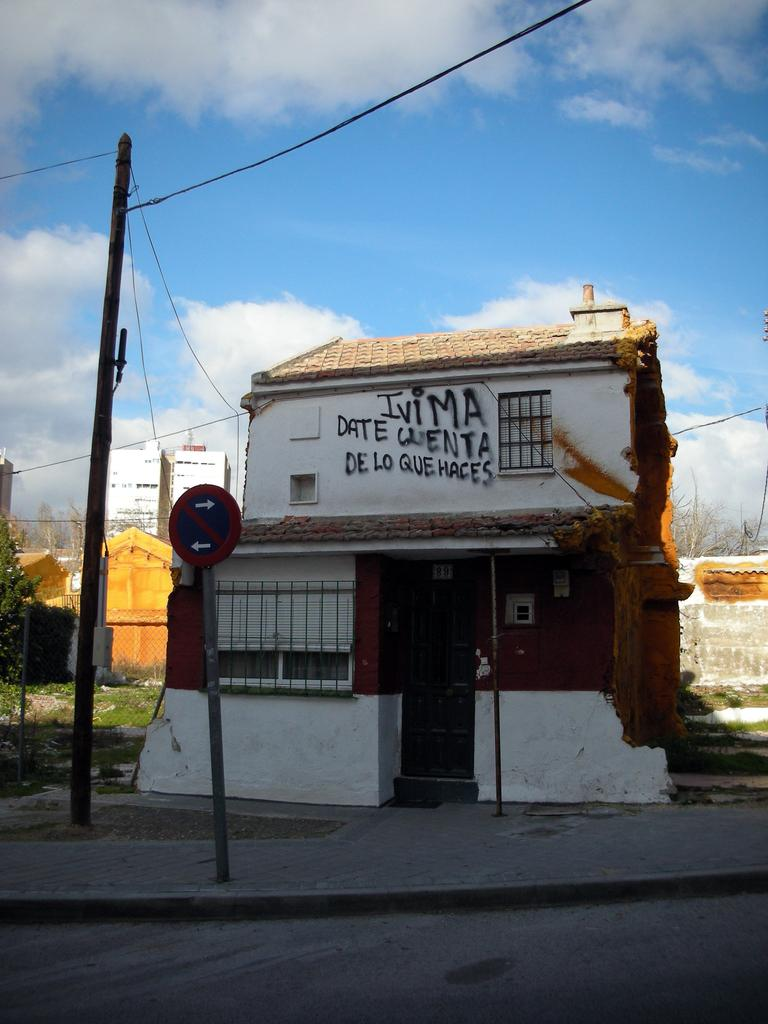What structure is located in the middle of the image? There is a house in the middle of the image. What can be seen on the left side of the image? There is a pole on the left side of the image. What is visible at the top of the image? The sky is visible at the top of the image. How many dolls are sitting on the roof of the house in the image? There are no dolls present in the image; it only features a house and a pole. What type of food is being prepared in the kitchen of the house in the image? There is no kitchen or food preparation visible in the image. 